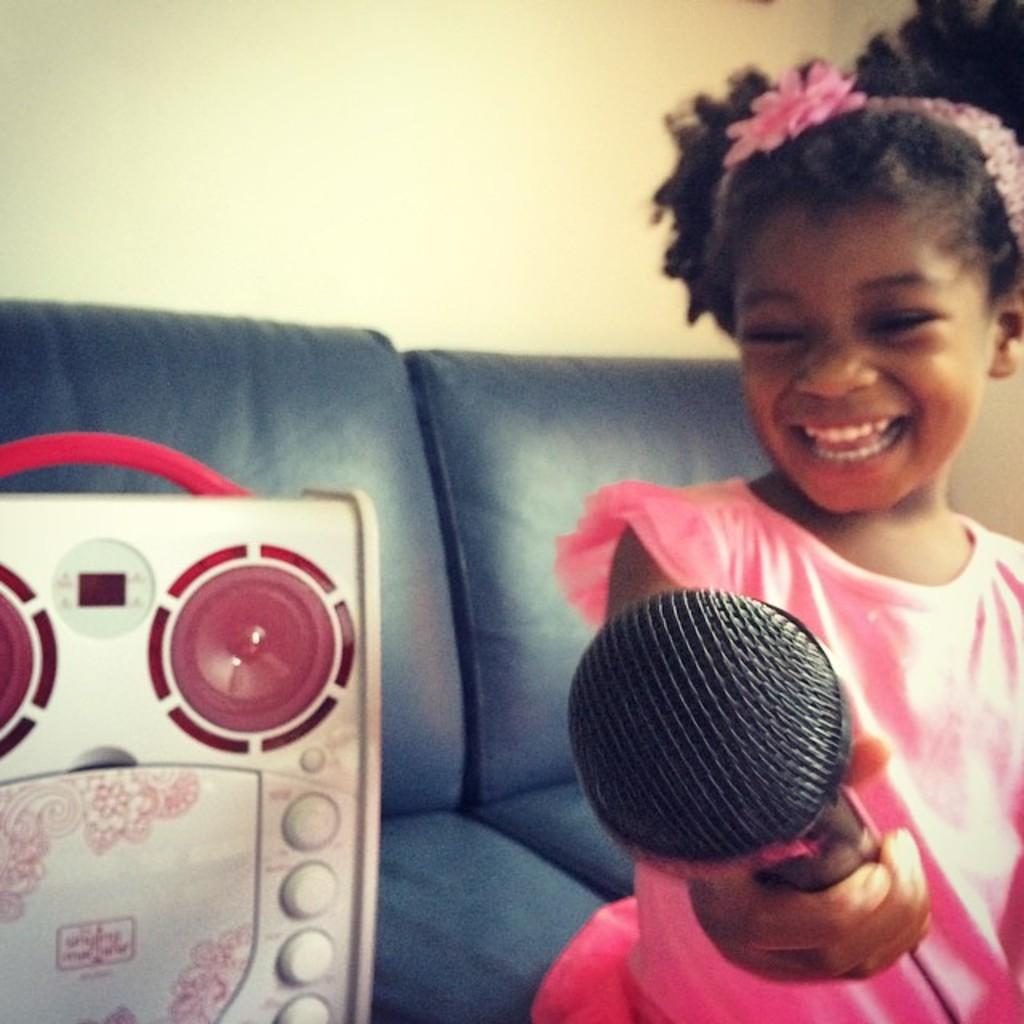Who is the main subject in the image? There is a girl in the image. What is the girl holding in the image? The girl is holding a microphone. What can be seen in the background of the image? There is a speaker and a sofa in the background of the image. What type of cheese is present on the girl's head in the image? There is no cheese present on the girl's head in the image. Can you see a crown on the girl's head in the image? There is no crown visible on the girl's head in the image. 